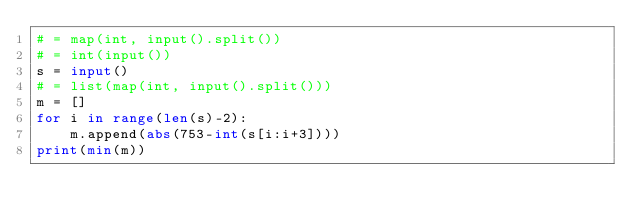Convert code to text. <code><loc_0><loc_0><loc_500><loc_500><_Python_># = map(int, input().split())
# = int(input())
s = input()
# = list(map(int, input().split()))
m = []
for i in range(len(s)-2):
	m.append(abs(753-int(s[i:i+3])))
print(min(m))</code> 